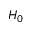<formula> <loc_0><loc_0><loc_500><loc_500>H _ { 0 }</formula> 